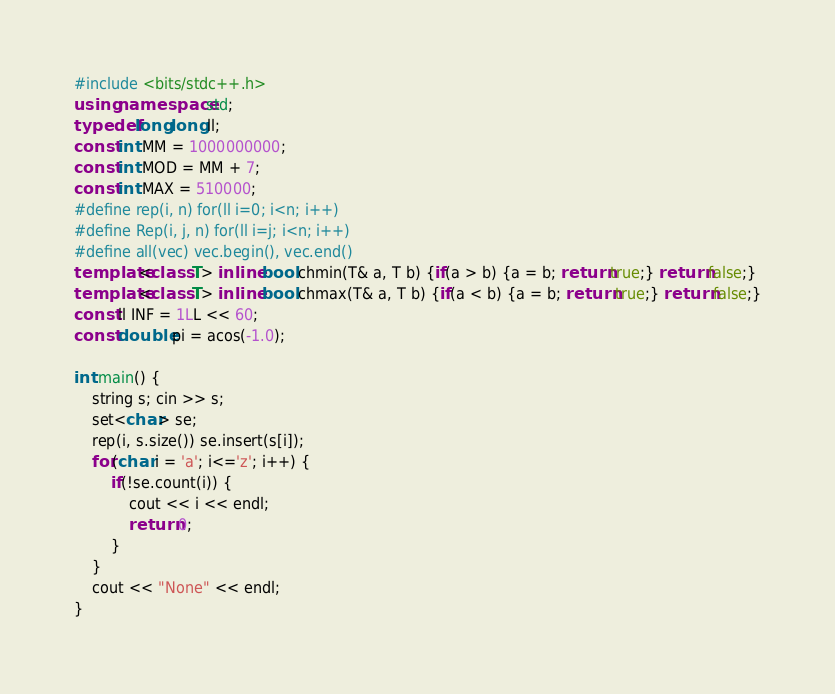Convert code to text. <code><loc_0><loc_0><loc_500><loc_500><_C++_>#include <bits/stdc++.h>
using namespace std;
typedef long long ll;
const int MM = 1000000000;
const int MOD = MM + 7;
const int MAX = 510000;
#define rep(i, n) for(ll i=0; i<n; i++)
#define Rep(i, j, n) for(ll i=j; i<n; i++)
#define all(vec) vec.begin(), vec.end()
template<class T> inline bool chmin(T& a, T b) {if(a > b) {a = b; return true;} return false;}
template<class T> inline bool chmax(T& a, T b) {if(a < b) {a = b; return true;} return false;}
const ll INF = 1LL << 60;
const double pi = acos(-1.0);

int main() {
    string s; cin >> s;
    set<char> se;
    rep(i, s.size()) se.insert(s[i]);
    for(char i = 'a'; i<='z'; i++) {
        if(!se.count(i)) {
            cout << i << endl;
            return 0;
        }
    }
    cout << "None" << endl;
}</code> 